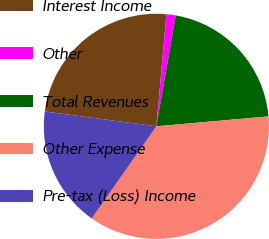Convert chart to OTSL. <chart><loc_0><loc_0><loc_500><loc_500><pie_chart><fcel>Interest Income<fcel>Other<fcel>Total Revenues<fcel>Other Expense<fcel>Pre-tax (Loss) Income<nl><fcel>24.32%<fcel>1.34%<fcel>20.84%<fcel>36.15%<fcel>17.36%<nl></chart> 